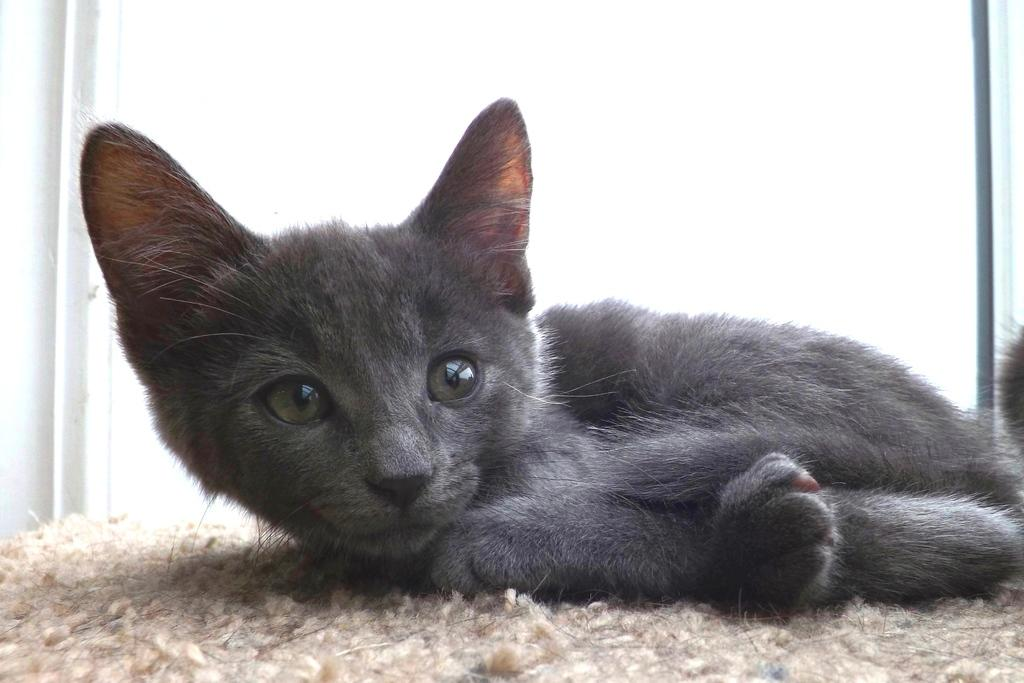What type of animal is in the image? There is a black kitten in the image. What color is the kitten? The kitten is black. What is the background color in the image? The background of the image is white. How many times does the kitten use the brake in the image? There is no brake present in the image, as it features a black kitten on a white background. 